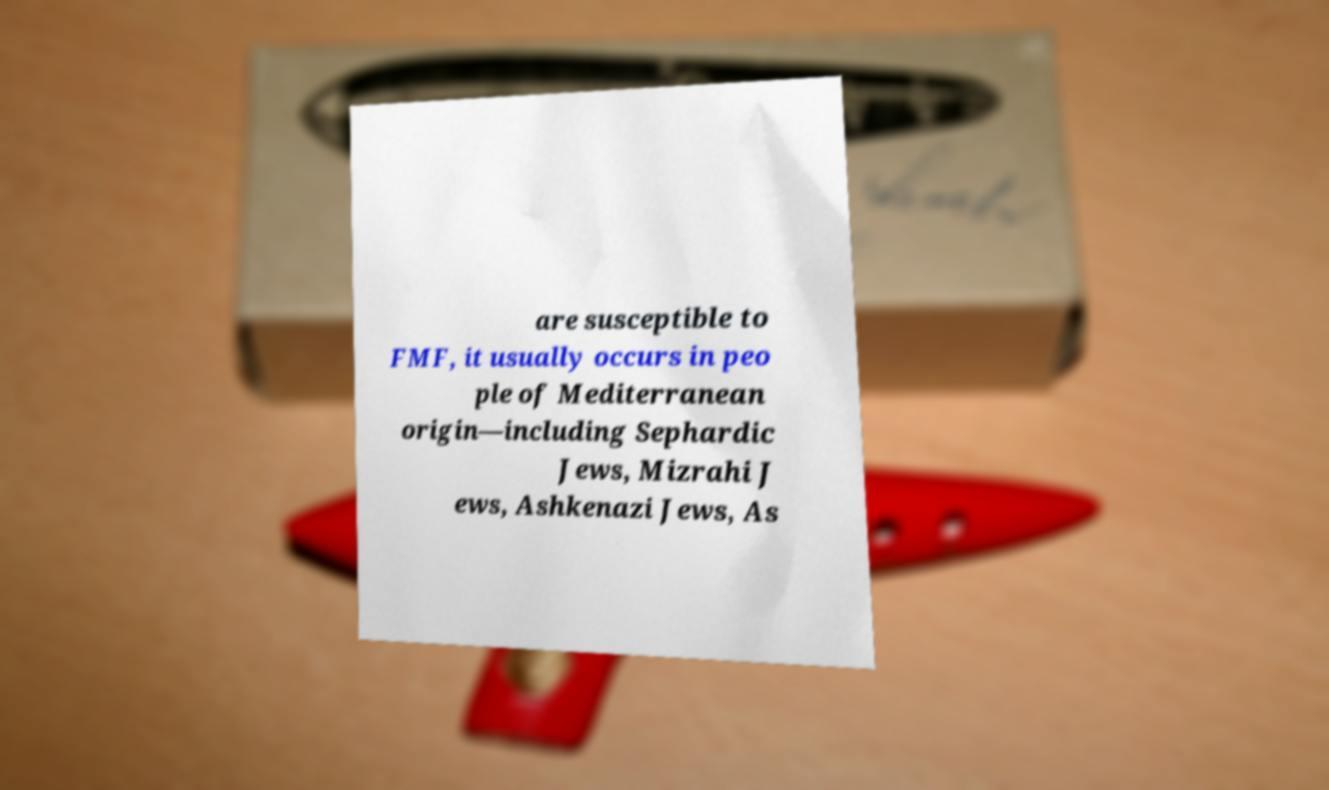What messages or text are displayed in this image? I need them in a readable, typed format. are susceptible to FMF, it usually occurs in peo ple of Mediterranean origin—including Sephardic Jews, Mizrahi J ews, Ashkenazi Jews, As 